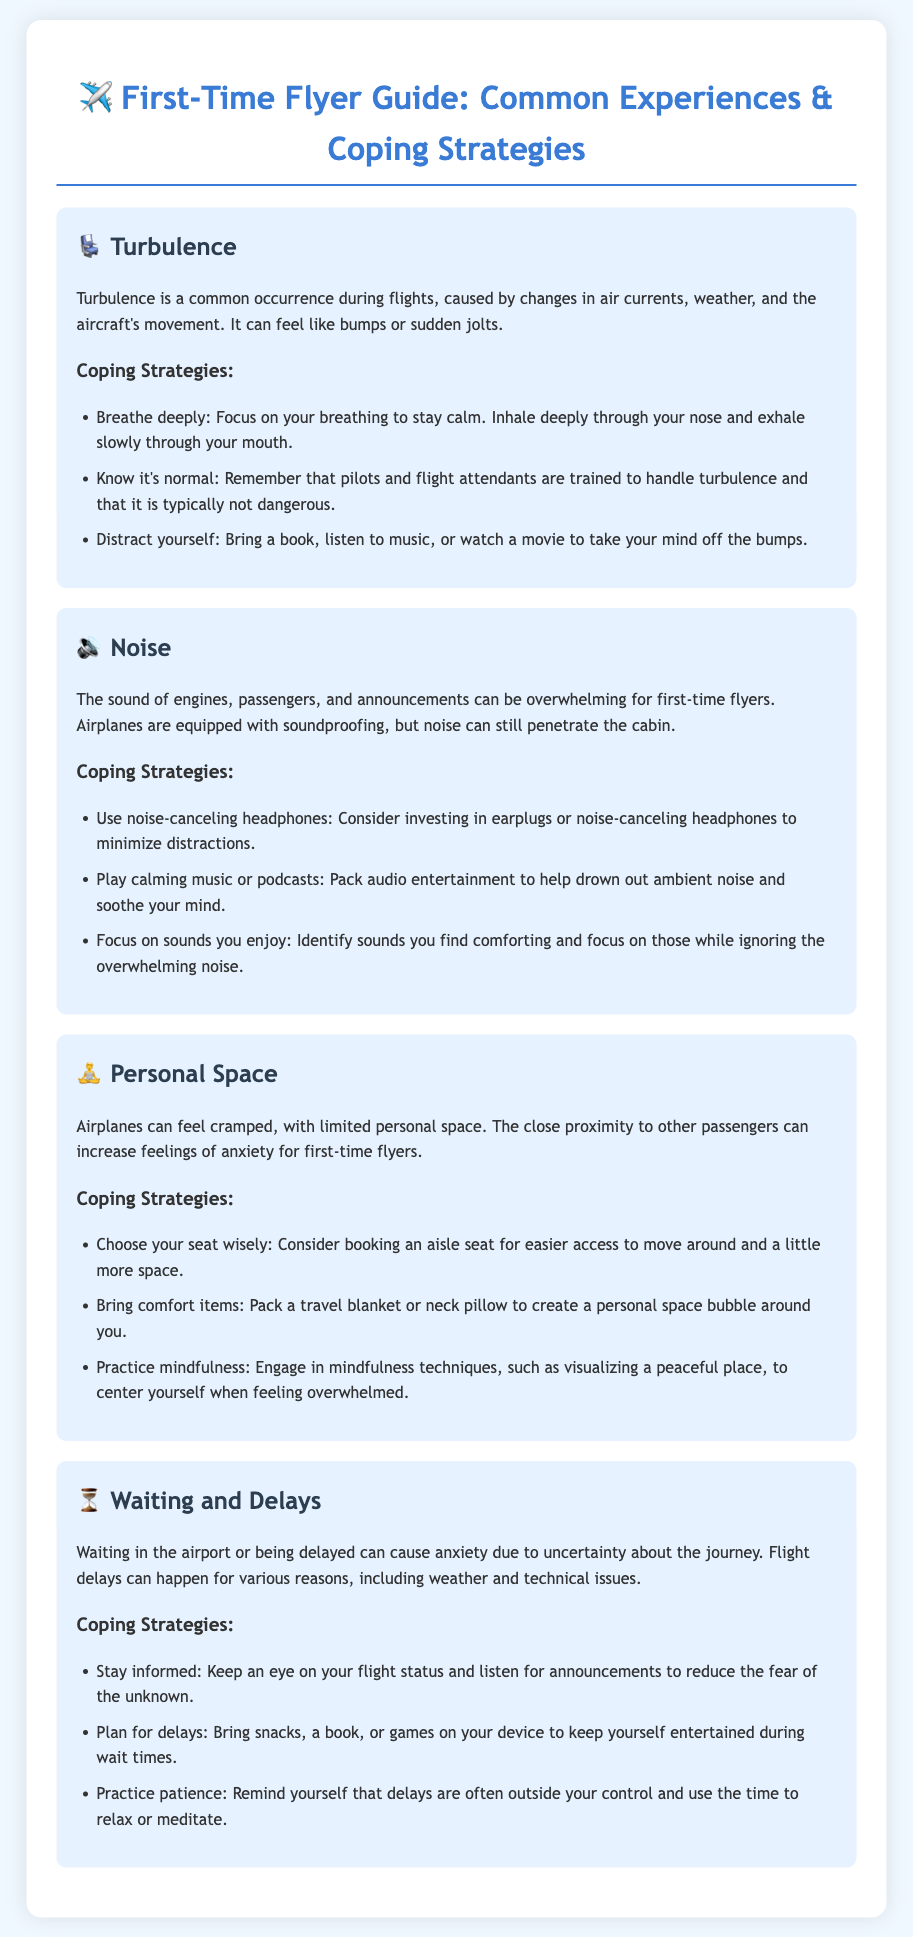What is the title of the guide? The title of the guide is clearly stated at the top of the document.
Answer: First-Time Flyer Guide: Common Experiences & Coping Strategies What effect does turbulence have during a flight? Turbulence is described as causing bumps or sudden jolts during a flight.
Answer: Bumps or sudden jolts What sort of headphones can help with noise? The document mentions a specific type of headphones that can minimize distractions from noise.
Answer: Noise-canceling headphones What is a recommended seat choice for more space? The document suggests a specific type of seat to help with feelings of space.
Answer: Aisle seat What relaxation technique is suggested for personal space issues? A mindfulness technique is mentioned in relation to managing anxiety about personal space.
Answer: Visualizing a peaceful place What can you bring to help cope with waiting and delays? The document lists several items one can bring to cope with anxiety during delays.
Answer: Snacks, a book, or games How is turbulence characterized in the document? The document provides an explanation of turbulence and its causes.
Answer: A common occurrence What is the main emotion addressed in relation to flying for the first time? The guide highlights a specific emotional response experienced by first-time flyers.
Answer: Anxiety What can you do to handle a flight delay effectively? The document offers advice on a specific coping strategy during delays at the airport.
Answer: Stay informed 